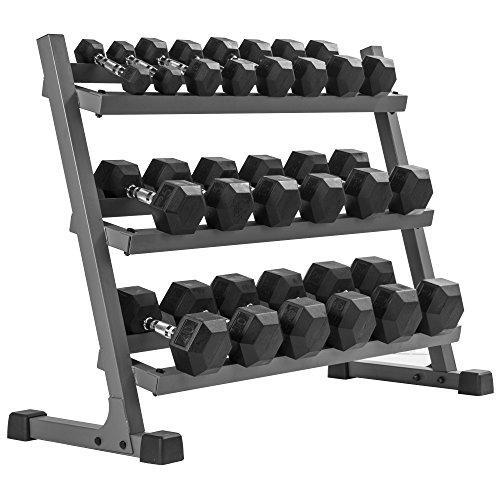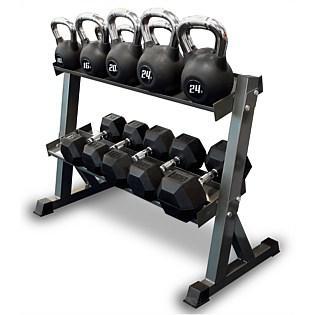The first image is the image on the left, the second image is the image on the right. Considering the images on both sides, is "The weights on the rack in the image on the left are round." valid? Answer yes or no. No. The first image is the image on the left, the second image is the image on the right. For the images displayed, is the sentence "One image shows a weight rack that holds three rows of dumbbells with hexagon-shaped ends." factually correct? Answer yes or no. Yes. 